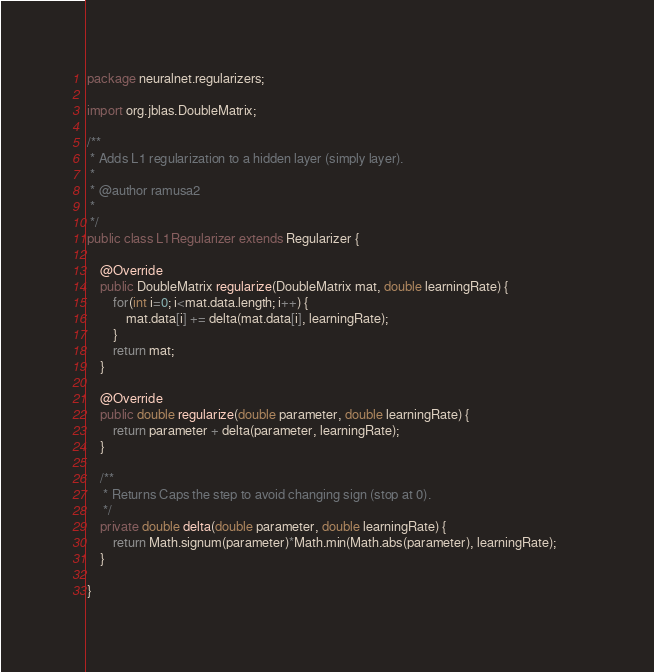<code> <loc_0><loc_0><loc_500><loc_500><_Java_>package neuralnet.regularizers;

import org.jblas.DoubleMatrix;

/**
 * Adds L1 regularization to a hidden layer (simply layer).
 * 
 * @author ramusa2
 *
 */
public class L1Regularizer extends Regularizer {

	@Override
	public DoubleMatrix regularize(DoubleMatrix mat, double learningRate) {
		for(int i=0; i<mat.data.length; i++) {
			mat.data[i] += delta(mat.data[i], learningRate);
		}
		return mat;
	}

	@Override
	public double regularize(double parameter, double learningRate) {
		return parameter + delta(parameter, learningRate);
	}
	
	/**
	 * Returns Caps the step to avoid changing sign (stop at 0).
	 */
	private double delta(double parameter, double learningRate) {
		return Math.signum(parameter)*Math.min(Math.abs(parameter), learningRate);		
	}

}
</code> 